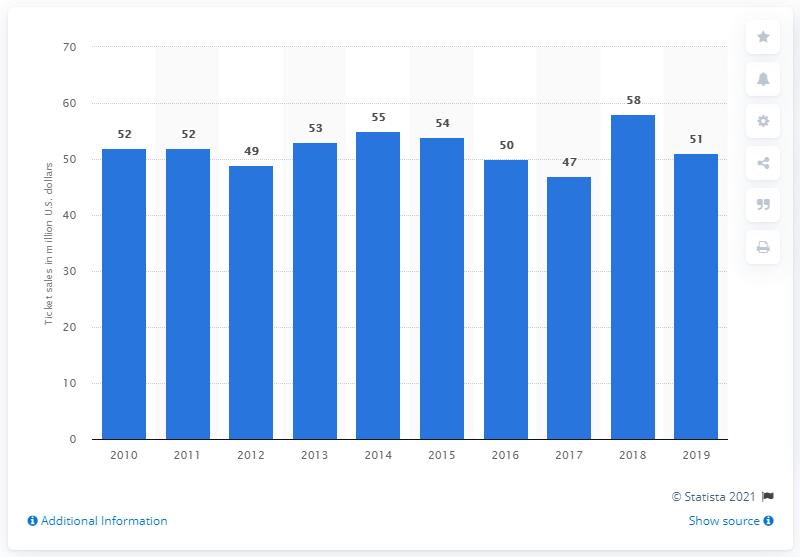Draw attention to some important aspects in this diagram. The Los Angeles Chargers generated $51 million in revenue from gate receipts in 2019. 